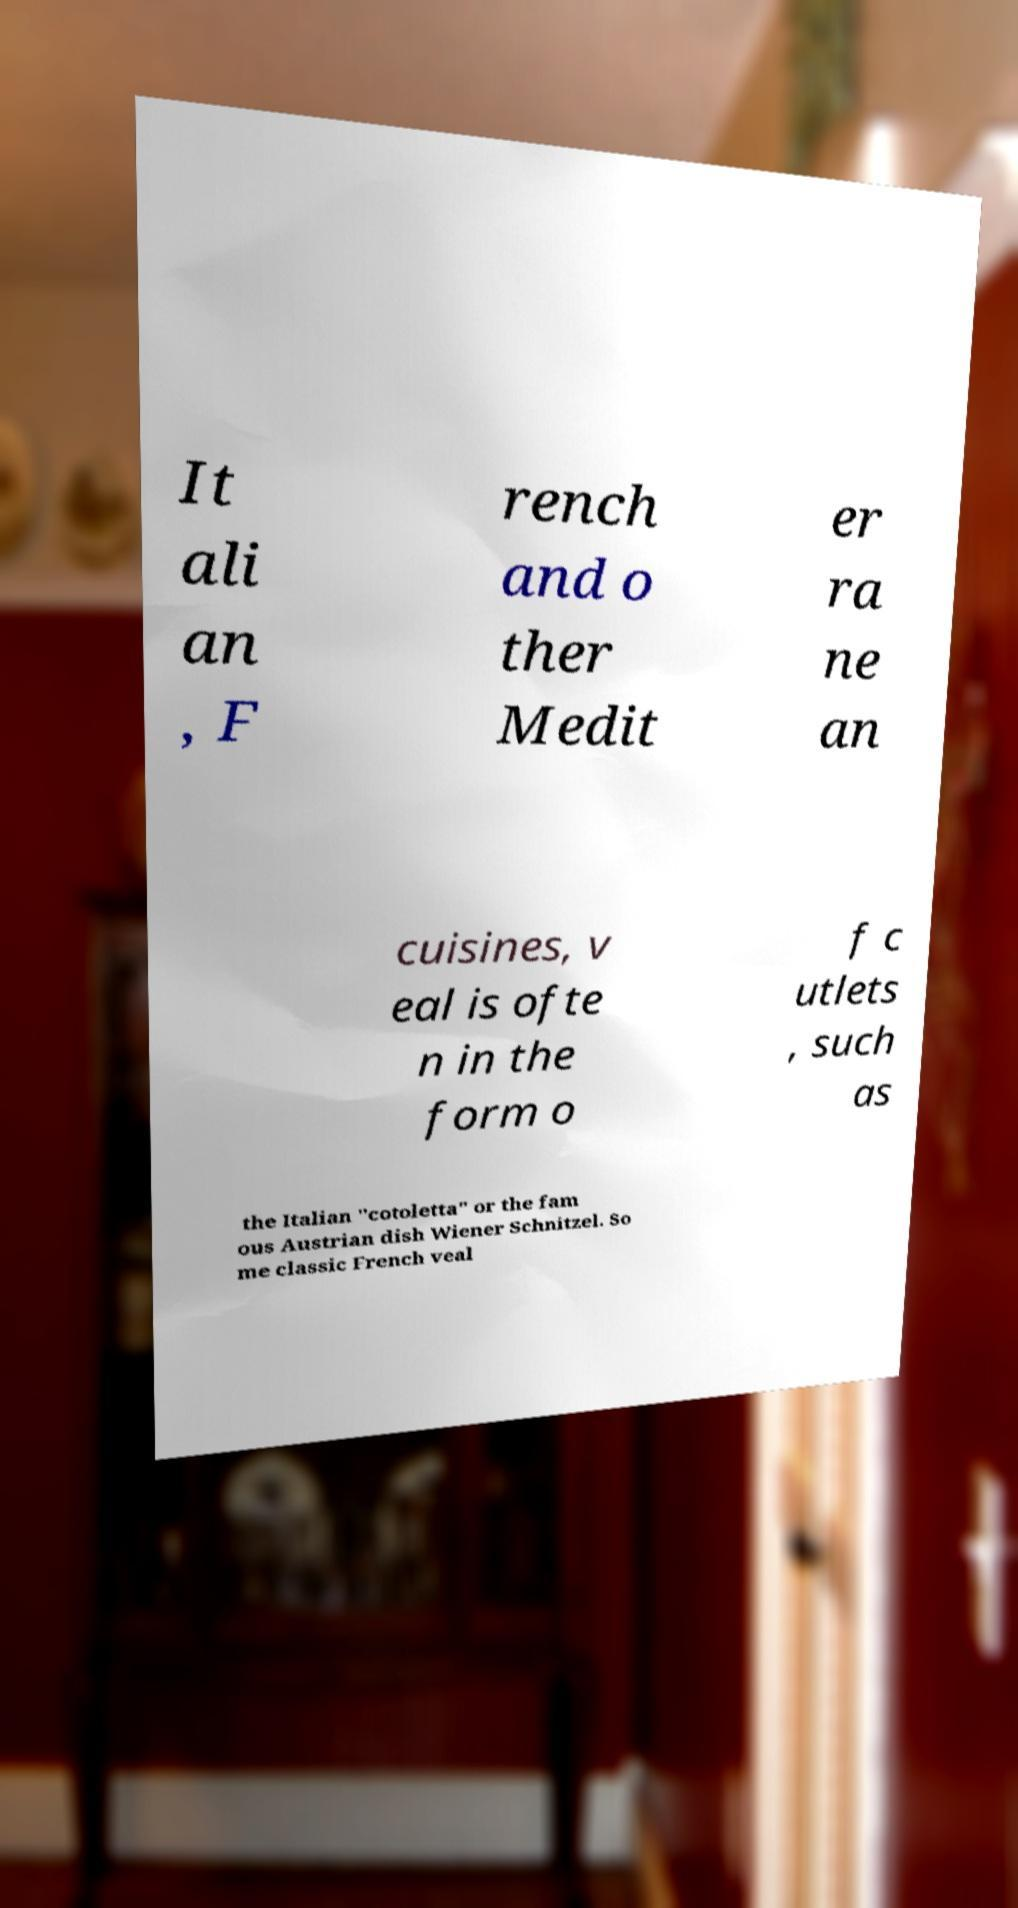I need the written content from this picture converted into text. Can you do that? It ali an , F rench and o ther Medit er ra ne an cuisines, v eal is ofte n in the form o f c utlets , such as the Italian "cotoletta" or the fam ous Austrian dish Wiener Schnitzel. So me classic French veal 